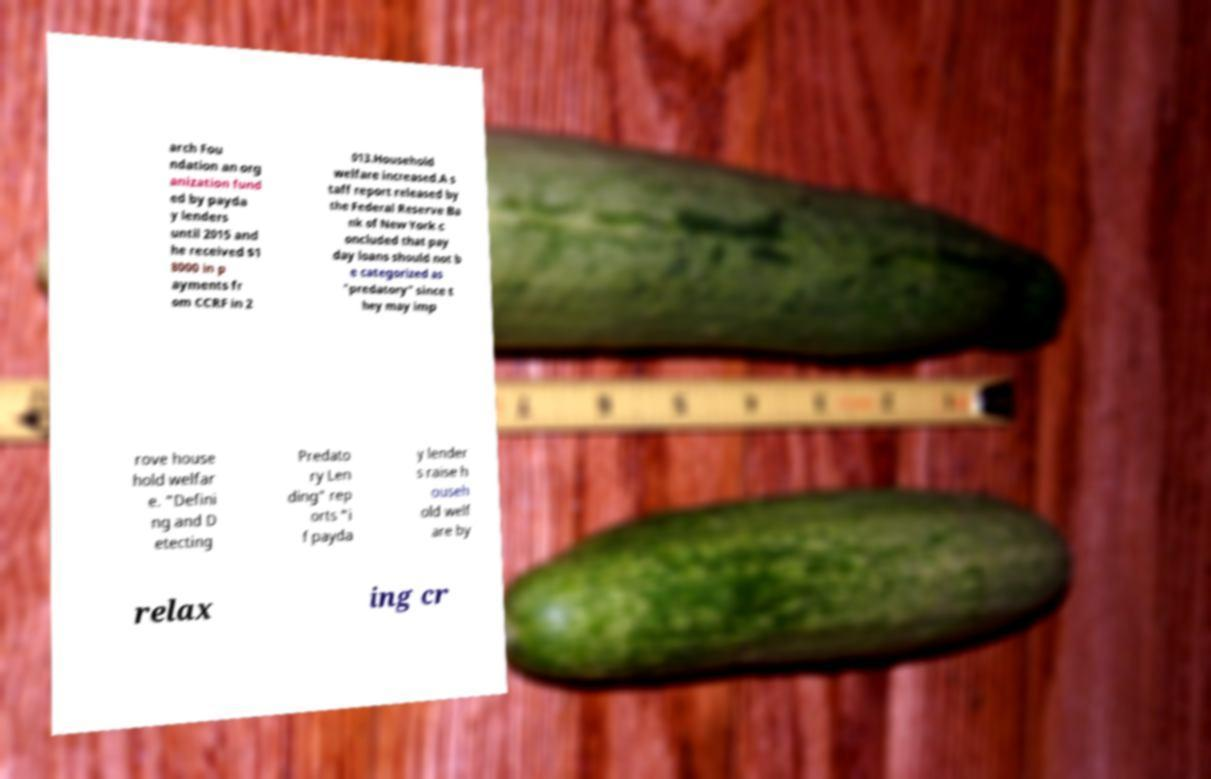I need the written content from this picture converted into text. Can you do that? arch Fou ndation an org anization fund ed by payda y lenders until 2015 and he received $1 8000 in p ayments fr om CCRF in 2 013.Household welfare increased.A s taff report released by the Federal Reserve Ba nk of New York c oncluded that pay day loans should not b e categorized as "predatory" since t hey may imp rove house hold welfar e. "Defini ng and D etecting Predato ry Len ding" rep orts "i f payda y lender s raise h ouseh old welf are by relax ing cr 